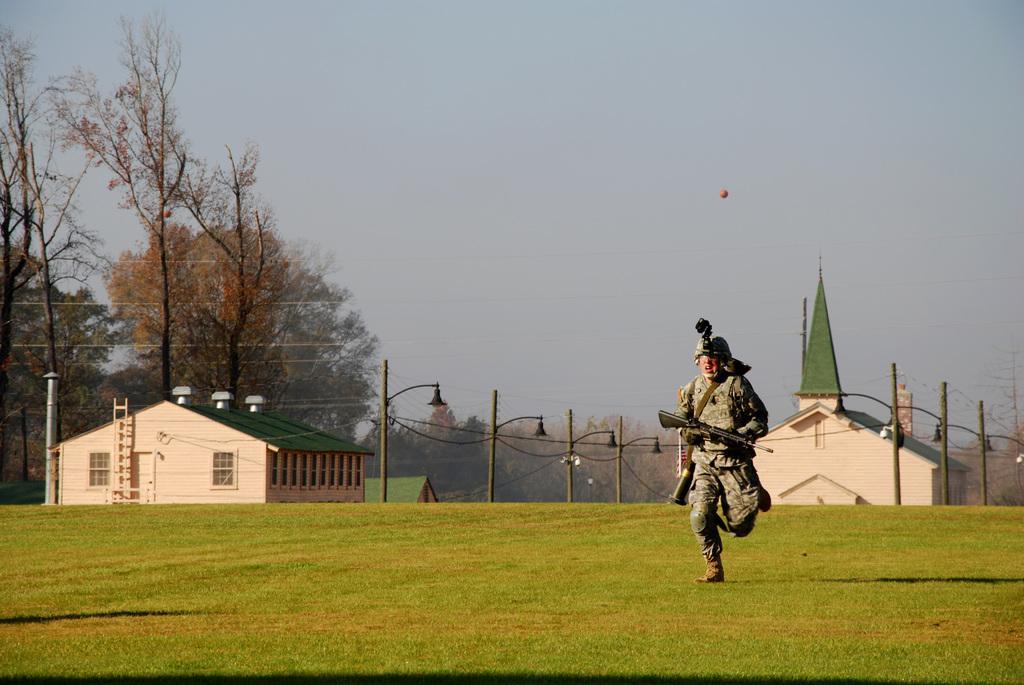Could you give a brief overview of what you see in this image? On the right side a man wore army dress, holding the weapon and running in the ground. In this image there are shirts, on the left side there are trees, at the top it is the sky. 